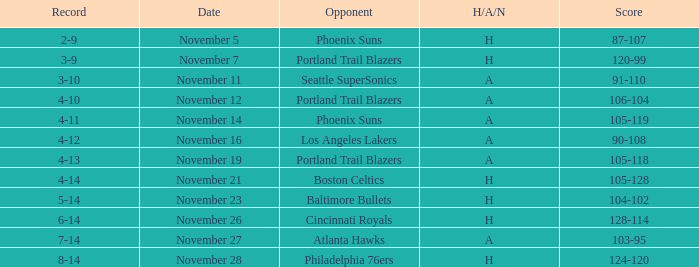What was the Opponent when the Cavaliers had a Record of 3-9? Portland Trail Blazers. 